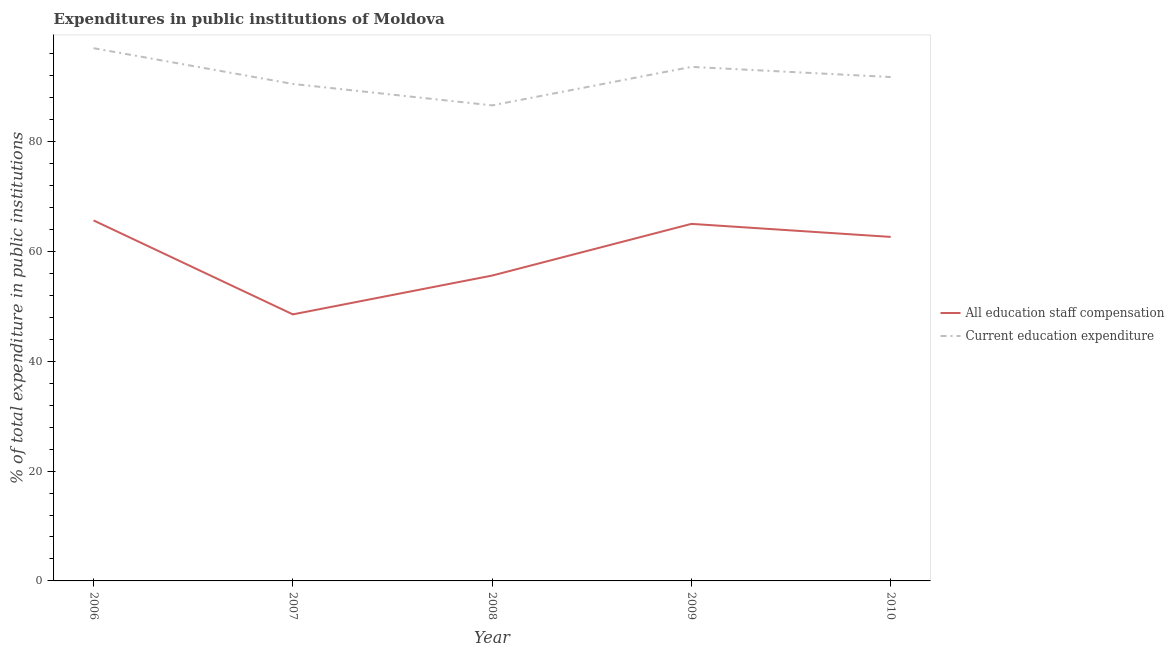How many different coloured lines are there?
Provide a succinct answer. 2. What is the expenditure in education in 2006?
Offer a terse response. 97.02. Across all years, what is the maximum expenditure in staff compensation?
Your response must be concise. 65.65. Across all years, what is the minimum expenditure in education?
Give a very brief answer. 86.6. In which year was the expenditure in education maximum?
Give a very brief answer. 2006. In which year was the expenditure in education minimum?
Provide a short and direct response. 2008. What is the total expenditure in education in the graph?
Your answer should be compact. 459.5. What is the difference between the expenditure in education in 2008 and that in 2009?
Give a very brief answer. -7.01. What is the difference between the expenditure in staff compensation in 2007 and the expenditure in education in 2010?
Give a very brief answer. -43.22. What is the average expenditure in education per year?
Provide a succinct answer. 91.9. In the year 2009, what is the difference between the expenditure in staff compensation and expenditure in education?
Your answer should be compact. -28.59. In how many years, is the expenditure in education greater than 32 %?
Ensure brevity in your answer.  5. What is the ratio of the expenditure in staff compensation in 2007 to that in 2010?
Ensure brevity in your answer.  0.77. Is the expenditure in education in 2008 less than that in 2009?
Give a very brief answer. Yes. Is the difference between the expenditure in staff compensation in 2006 and 2010 greater than the difference between the expenditure in education in 2006 and 2010?
Ensure brevity in your answer.  No. What is the difference between the highest and the second highest expenditure in staff compensation?
Offer a very short reply. 0.63. What is the difference between the highest and the lowest expenditure in staff compensation?
Your response must be concise. 17.11. Is the sum of the expenditure in staff compensation in 2007 and 2010 greater than the maximum expenditure in education across all years?
Your answer should be compact. Yes. Does the expenditure in staff compensation monotonically increase over the years?
Your answer should be very brief. No. Is the expenditure in staff compensation strictly less than the expenditure in education over the years?
Give a very brief answer. Yes. How many years are there in the graph?
Keep it short and to the point. 5. What is the difference between two consecutive major ticks on the Y-axis?
Your answer should be very brief. 20. Does the graph contain grids?
Provide a succinct answer. No. Where does the legend appear in the graph?
Give a very brief answer. Center right. How are the legend labels stacked?
Your response must be concise. Vertical. What is the title of the graph?
Your response must be concise. Expenditures in public institutions of Moldova. Does "Taxes on profits and capital gains" appear as one of the legend labels in the graph?
Provide a short and direct response. No. What is the label or title of the X-axis?
Ensure brevity in your answer.  Year. What is the label or title of the Y-axis?
Offer a terse response. % of total expenditure in public institutions. What is the % of total expenditure in public institutions in All education staff compensation in 2006?
Offer a terse response. 65.65. What is the % of total expenditure in public institutions of Current education expenditure in 2006?
Keep it short and to the point. 97.02. What is the % of total expenditure in public institutions in All education staff compensation in 2007?
Make the answer very short. 48.54. What is the % of total expenditure in public institutions in Current education expenditure in 2007?
Offer a very short reply. 90.51. What is the % of total expenditure in public institutions of All education staff compensation in 2008?
Your answer should be compact. 55.61. What is the % of total expenditure in public institutions in Current education expenditure in 2008?
Your answer should be very brief. 86.6. What is the % of total expenditure in public institutions of All education staff compensation in 2009?
Make the answer very short. 65.02. What is the % of total expenditure in public institutions of Current education expenditure in 2009?
Offer a terse response. 93.61. What is the % of total expenditure in public institutions in All education staff compensation in 2010?
Make the answer very short. 62.65. What is the % of total expenditure in public institutions in Current education expenditure in 2010?
Offer a very short reply. 91.76. Across all years, what is the maximum % of total expenditure in public institutions in All education staff compensation?
Your answer should be compact. 65.65. Across all years, what is the maximum % of total expenditure in public institutions of Current education expenditure?
Provide a short and direct response. 97.02. Across all years, what is the minimum % of total expenditure in public institutions in All education staff compensation?
Provide a short and direct response. 48.54. Across all years, what is the minimum % of total expenditure in public institutions in Current education expenditure?
Offer a very short reply. 86.6. What is the total % of total expenditure in public institutions in All education staff compensation in the graph?
Make the answer very short. 297.47. What is the total % of total expenditure in public institutions of Current education expenditure in the graph?
Offer a terse response. 459.5. What is the difference between the % of total expenditure in public institutions of All education staff compensation in 2006 and that in 2007?
Ensure brevity in your answer.  17.11. What is the difference between the % of total expenditure in public institutions of Current education expenditure in 2006 and that in 2007?
Provide a short and direct response. 6.51. What is the difference between the % of total expenditure in public institutions of All education staff compensation in 2006 and that in 2008?
Give a very brief answer. 10.04. What is the difference between the % of total expenditure in public institutions of Current education expenditure in 2006 and that in 2008?
Your answer should be very brief. 10.41. What is the difference between the % of total expenditure in public institutions in All education staff compensation in 2006 and that in 2009?
Keep it short and to the point. 0.63. What is the difference between the % of total expenditure in public institutions of Current education expenditure in 2006 and that in 2009?
Your answer should be very brief. 3.41. What is the difference between the % of total expenditure in public institutions in All education staff compensation in 2006 and that in 2010?
Ensure brevity in your answer.  3. What is the difference between the % of total expenditure in public institutions in Current education expenditure in 2006 and that in 2010?
Your answer should be compact. 5.26. What is the difference between the % of total expenditure in public institutions in All education staff compensation in 2007 and that in 2008?
Give a very brief answer. -7.07. What is the difference between the % of total expenditure in public institutions in Current education expenditure in 2007 and that in 2008?
Offer a terse response. 3.9. What is the difference between the % of total expenditure in public institutions in All education staff compensation in 2007 and that in 2009?
Give a very brief answer. -16.48. What is the difference between the % of total expenditure in public institutions of Current education expenditure in 2007 and that in 2009?
Provide a succinct answer. -3.1. What is the difference between the % of total expenditure in public institutions of All education staff compensation in 2007 and that in 2010?
Your answer should be compact. -14.11. What is the difference between the % of total expenditure in public institutions in Current education expenditure in 2007 and that in 2010?
Ensure brevity in your answer.  -1.26. What is the difference between the % of total expenditure in public institutions of All education staff compensation in 2008 and that in 2009?
Your response must be concise. -9.41. What is the difference between the % of total expenditure in public institutions in Current education expenditure in 2008 and that in 2009?
Provide a succinct answer. -7.01. What is the difference between the % of total expenditure in public institutions of All education staff compensation in 2008 and that in 2010?
Your answer should be very brief. -7.04. What is the difference between the % of total expenditure in public institutions of Current education expenditure in 2008 and that in 2010?
Give a very brief answer. -5.16. What is the difference between the % of total expenditure in public institutions in All education staff compensation in 2009 and that in 2010?
Provide a short and direct response. 2.37. What is the difference between the % of total expenditure in public institutions in Current education expenditure in 2009 and that in 2010?
Your answer should be compact. 1.85. What is the difference between the % of total expenditure in public institutions of All education staff compensation in 2006 and the % of total expenditure in public institutions of Current education expenditure in 2007?
Your answer should be very brief. -24.85. What is the difference between the % of total expenditure in public institutions of All education staff compensation in 2006 and the % of total expenditure in public institutions of Current education expenditure in 2008?
Your answer should be very brief. -20.95. What is the difference between the % of total expenditure in public institutions in All education staff compensation in 2006 and the % of total expenditure in public institutions in Current education expenditure in 2009?
Offer a very short reply. -27.96. What is the difference between the % of total expenditure in public institutions of All education staff compensation in 2006 and the % of total expenditure in public institutions of Current education expenditure in 2010?
Offer a terse response. -26.11. What is the difference between the % of total expenditure in public institutions in All education staff compensation in 2007 and the % of total expenditure in public institutions in Current education expenditure in 2008?
Make the answer very short. -38.06. What is the difference between the % of total expenditure in public institutions in All education staff compensation in 2007 and the % of total expenditure in public institutions in Current education expenditure in 2009?
Offer a terse response. -45.07. What is the difference between the % of total expenditure in public institutions in All education staff compensation in 2007 and the % of total expenditure in public institutions in Current education expenditure in 2010?
Provide a short and direct response. -43.22. What is the difference between the % of total expenditure in public institutions of All education staff compensation in 2008 and the % of total expenditure in public institutions of Current education expenditure in 2009?
Your answer should be very brief. -38. What is the difference between the % of total expenditure in public institutions of All education staff compensation in 2008 and the % of total expenditure in public institutions of Current education expenditure in 2010?
Provide a succinct answer. -36.15. What is the difference between the % of total expenditure in public institutions of All education staff compensation in 2009 and the % of total expenditure in public institutions of Current education expenditure in 2010?
Offer a very short reply. -26.74. What is the average % of total expenditure in public institutions in All education staff compensation per year?
Make the answer very short. 59.49. What is the average % of total expenditure in public institutions in Current education expenditure per year?
Provide a succinct answer. 91.9. In the year 2006, what is the difference between the % of total expenditure in public institutions in All education staff compensation and % of total expenditure in public institutions in Current education expenditure?
Keep it short and to the point. -31.37. In the year 2007, what is the difference between the % of total expenditure in public institutions in All education staff compensation and % of total expenditure in public institutions in Current education expenditure?
Provide a short and direct response. -41.96. In the year 2008, what is the difference between the % of total expenditure in public institutions in All education staff compensation and % of total expenditure in public institutions in Current education expenditure?
Offer a very short reply. -30.99. In the year 2009, what is the difference between the % of total expenditure in public institutions in All education staff compensation and % of total expenditure in public institutions in Current education expenditure?
Keep it short and to the point. -28.59. In the year 2010, what is the difference between the % of total expenditure in public institutions of All education staff compensation and % of total expenditure in public institutions of Current education expenditure?
Ensure brevity in your answer.  -29.11. What is the ratio of the % of total expenditure in public institutions in All education staff compensation in 2006 to that in 2007?
Your response must be concise. 1.35. What is the ratio of the % of total expenditure in public institutions in Current education expenditure in 2006 to that in 2007?
Offer a very short reply. 1.07. What is the ratio of the % of total expenditure in public institutions of All education staff compensation in 2006 to that in 2008?
Keep it short and to the point. 1.18. What is the ratio of the % of total expenditure in public institutions in Current education expenditure in 2006 to that in 2008?
Give a very brief answer. 1.12. What is the ratio of the % of total expenditure in public institutions of All education staff compensation in 2006 to that in 2009?
Your response must be concise. 1.01. What is the ratio of the % of total expenditure in public institutions in Current education expenditure in 2006 to that in 2009?
Offer a very short reply. 1.04. What is the ratio of the % of total expenditure in public institutions of All education staff compensation in 2006 to that in 2010?
Ensure brevity in your answer.  1.05. What is the ratio of the % of total expenditure in public institutions in Current education expenditure in 2006 to that in 2010?
Your response must be concise. 1.06. What is the ratio of the % of total expenditure in public institutions in All education staff compensation in 2007 to that in 2008?
Your answer should be very brief. 0.87. What is the ratio of the % of total expenditure in public institutions in Current education expenditure in 2007 to that in 2008?
Ensure brevity in your answer.  1.05. What is the ratio of the % of total expenditure in public institutions of All education staff compensation in 2007 to that in 2009?
Your answer should be very brief. 0.75. What is the ratio of the % of total expenditure in public institutions in Current education expenditure in 2007 to that in 2009?
Give a very brief answer. 0.97. What is the ratio of the % of total expenditure in public institutions of All education staff compensation in 2007 to that in 2010?
Your answer should be compact. 0.77. What is the ratio of the % of total expenditure in public institutions in Current education expenditure in 2007 to that in 2010?
Your answer should be very brief. 0.99. What is the ratio of the % of total expenditure in public institutions in All education staff compensation in 2008 to that in 2009?
Your answer should be very brief. 0.86. What is the ratio of the % of total expenditure in public institutions of Current education expenditure in 2008 to that in 2009?
Give a very brief answer. 0.93. What is the ratio of the % of total expenditure in public institutions in All education staff compensation in 2008 to that in 2010?
Your response must be concise. 0.89. What is the ratio of the % of total expenditure in public institutions of Current education expenditure in 2008 to that in 2010?
Ensure brevity in your answer.  0.94. What is the ratio of the % of total expenditure in public institutions in All education staff compensation in 2009 to that in 2010?
Offer a very short reply. 1.04. What is the ratio of the % of total expenditure in public institutions in Current education expenditure in 2009 to that in 2010?
Your answer should be very brief. 1.02. What is the difference between the highest and the second highest % of total expenditure in public institutions in All education staff compensation?
Offer a terse response. 0.63. What is the difference between the highest and the second highest % of total expenditure in public institutions in Current education expenditure?
Give a very brief answer. 3.41. What is the difference between the highest and the lowest % of total expenditure in public institutions of All education staff compensation?
Offer a very short reply. 17.11. What is the difference between the highest and the lowest % of total expenditure in public institutions in Current education expenditure?
Make the answer very short. 10.41. 